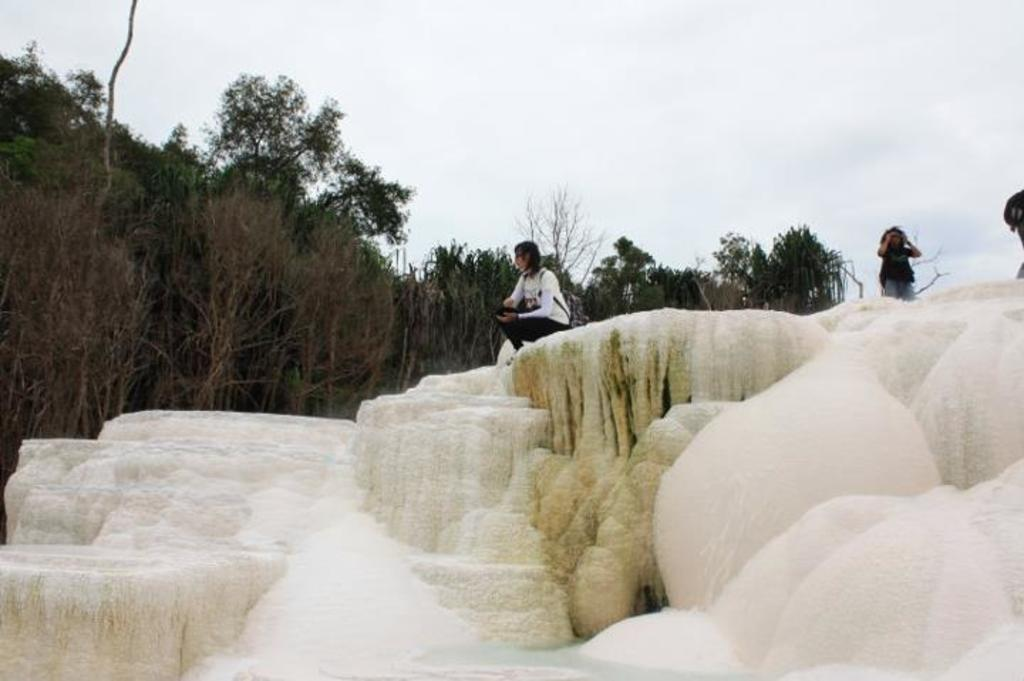How many people are in the image? There are two people in the image. What is the surface the people are standing on? The people are on the snow. What can be seen in the background of the image? There are trees and the sky visible in the background of the image. What type of bottle is being used to temper the snow in the image? There is no bottle or tempering of snow present in the image. 